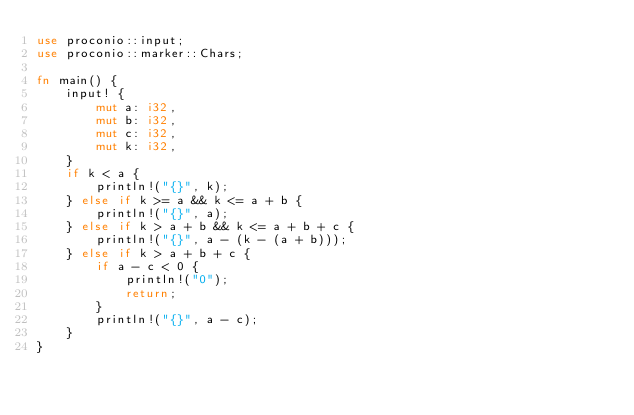<code> <loc_0><loc_0><loc_500><loc_500><_Rust_>use proconio::input;
use proconio::marker::Chars;

fn main() {
	input! {
		mut a: i32,
		mut b: i32,
		mut c: i32,
		mut k: i32,
	}
	if k < a {
		println!("{}", k);
	} else if k >= a && k <= a + b {
		println!("{}", a);
	} else if k > a + b && k <= a + b + c {
		println!("{}", a - (k - (a + b)));
	} else if k > a + b + c {
		if a - c < 0 {
			println!("0");
			return;
		}
		println!("{}", a - c);
	}
}
</code> 